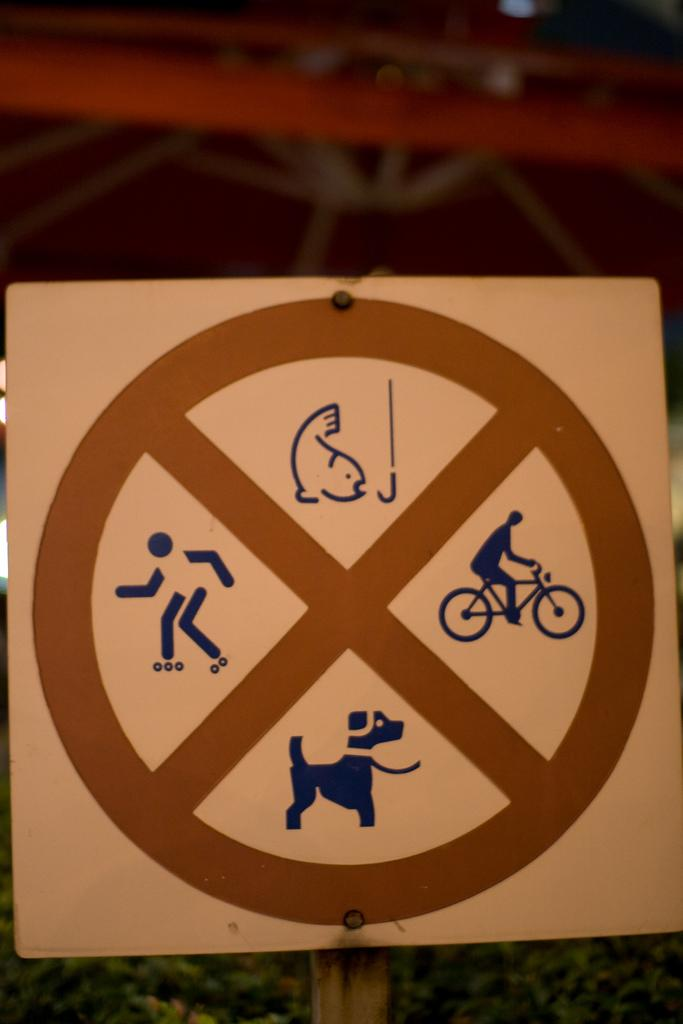What is present on the sign board in the image? There is a sign board in the image, and it features two animal images, person images, and a bicycle. Can you describe the animal images on the sign board? There are two animal images on the sign board, but their specific details are not visible in the image. What type of images are present alongside the animal images on the sign board? There are person images present alongside the animal images on the sign board. What mode of transportation is depicted on the sign board? A bicycle is depicted on the sign board. What type of collar is visible on the ground in the image? There is no collar visible on the ground in the image. Is there any exchange of goods or services happening in the image? There is no indication of any exchange of goods or services in the image. 